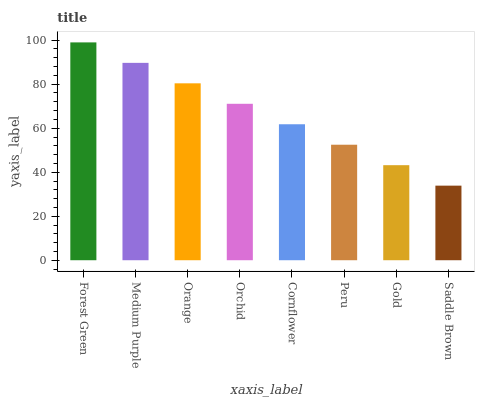Is Saddle Brown the minimum?
Answer yes or no. Yes. Is Forest Green the maximum?
Answer yes or no. Yes. Is Medium Purple the minimum?
Answer yes or no. No. Is Medium Purple the maximum?
Answer yes or no. No. Is Forest Green greater than Medium Purple?
Answer yes or no. Yes. Is Medium Purple less than Forest Green?
Answer yes or no. Yes. Is Medium Purple greater than Forest Green?
Answer yes or no. No. Is Forest Green less than Medium Purple?
Answer yes or no. No. Is Orchid the high median?
Answer yes or no. Yes. Is Cornflower the low median?
Answer yes or no. Yes. Is Gold the high median?
Answer yes or no. No. Is Forest Green the low median?
Answer yes or no. No. 